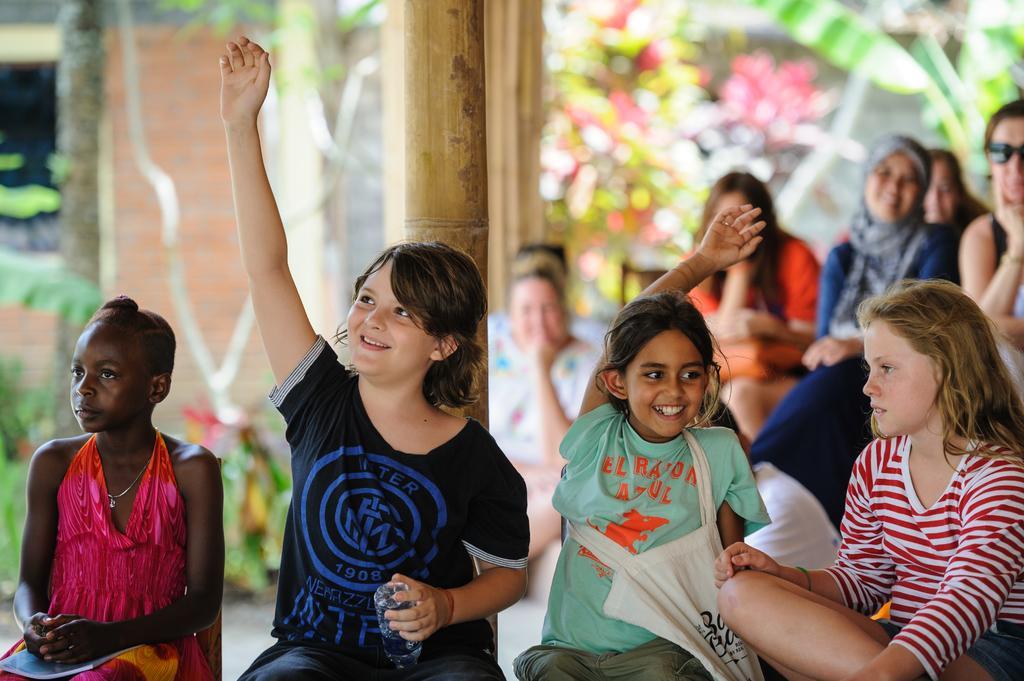Could you give a brief overview of what you see in this image? In the foreground of this image, there are girls sitting on the chairs, among them two girls are raising hands in the air and having smile on their faces. In the background, a pole, there are persons sitting on the chairs, few plants and the wall of a building. 